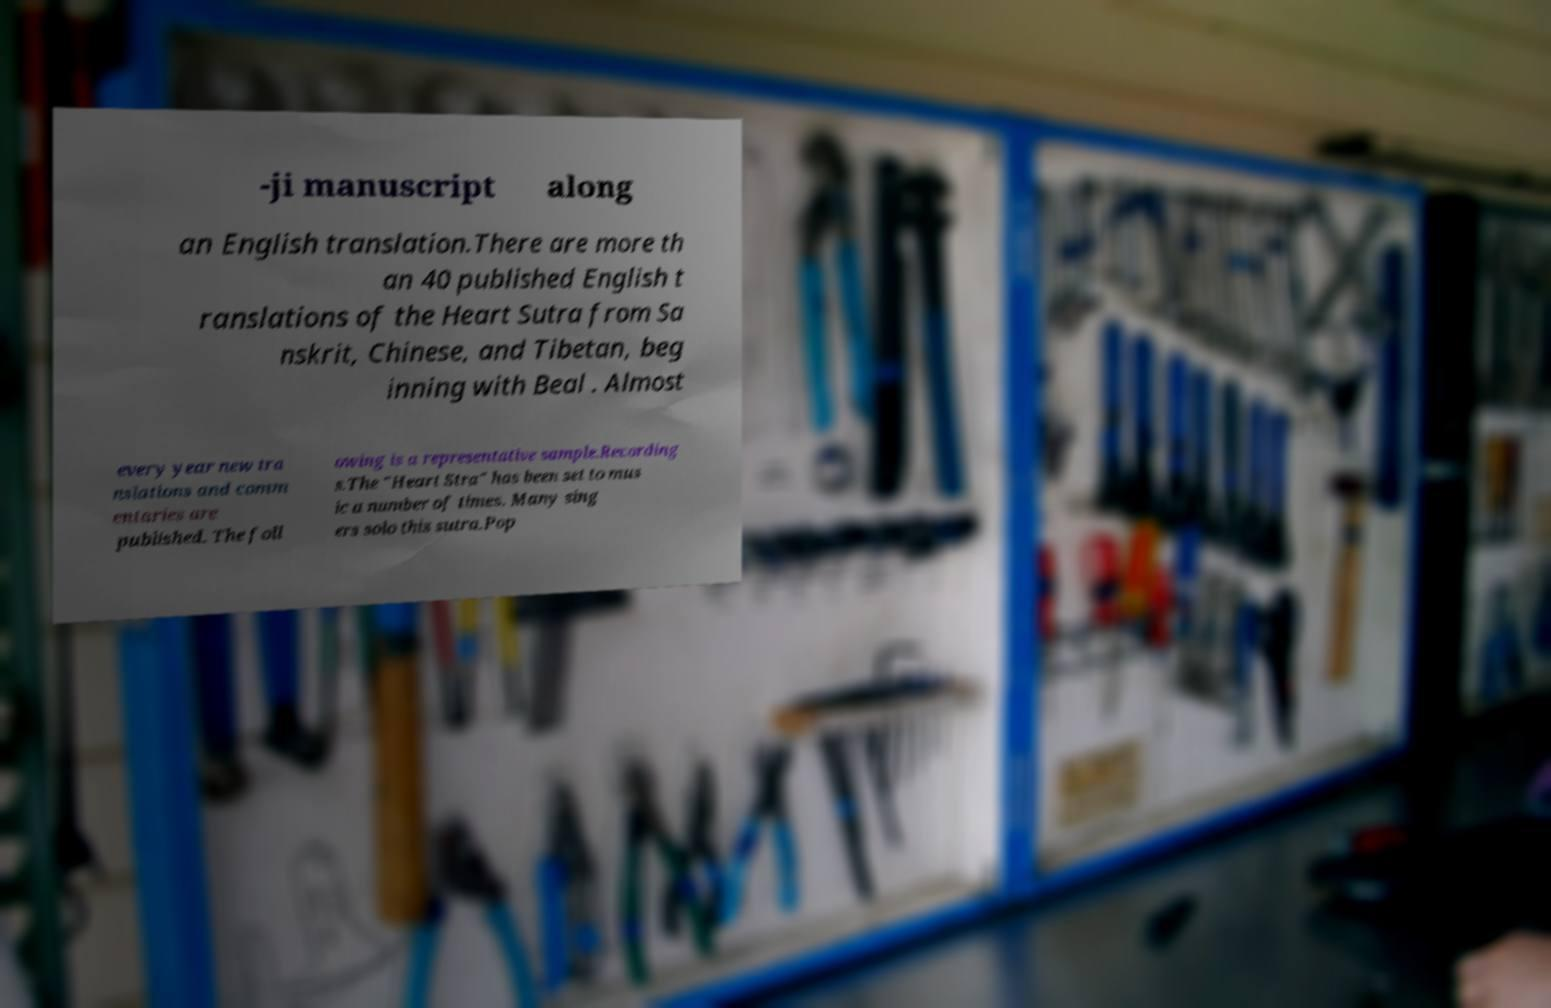Please read and relay the text visible in this image. What does it say? -ji manuscript along an English translation.There are more th an 40 published English t ranslations of the Heart Sutra from Sa nskrit, Chinese, and Tibetan, beg inning with Beal . Almost every year new tra nslations and comm entaries are published. The foll owing is a representative sample.Recording s.The "Heart Stra" has been set to mus ic a number of times. Many sing ers solo this sutra.Pop 